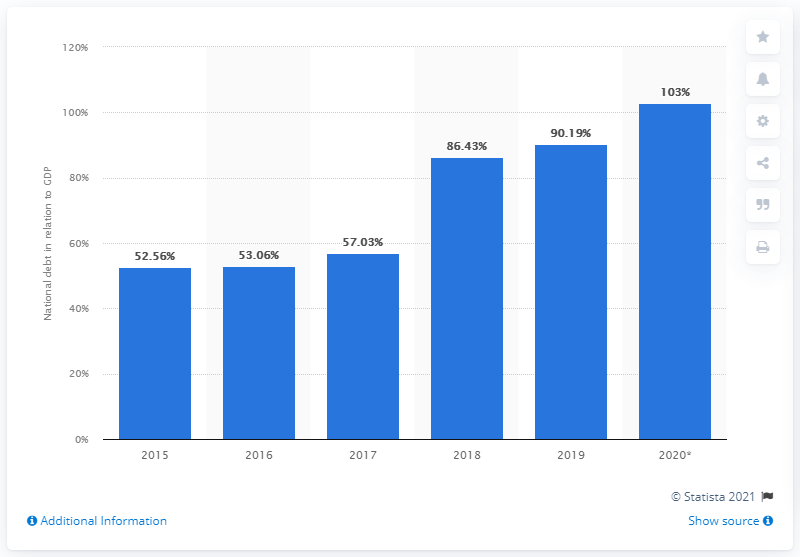Identify some key points in this picture. In 2019, Argentina's national debt constituted approximately 90.19% of the country's Gross Domestic Product (GDP). 